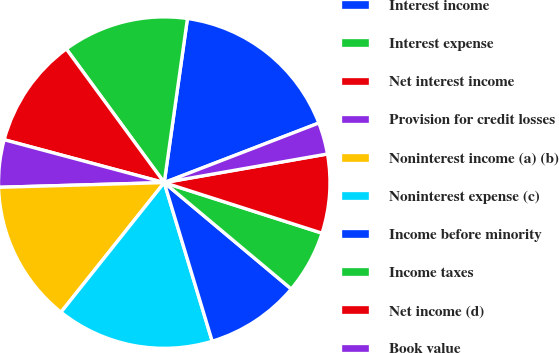Convert chart to OTSL. <chart><loc_0><loc_0><loc_500><loc_500><pie_chart><fcel>Interest income<fcel>Interest expense<fcel>Net interest income<fcel>Provision for credit losses<fcel>Noninterest income (a) (b)<fcel>Noninterest expense (c)<fcel>Income before minority<fcel>Income taxes<fcel>Net income (d)<fcel>Book value<nl><fcel>16.91%<fcel>12.3%<fcel>10.77%<fcel>4.62%<fcel>13.84%<fcel>15.38%<fcel>9.23%<fcel>6.16%<fcel>7.7%<fcel>3.09%<nl></chart> 